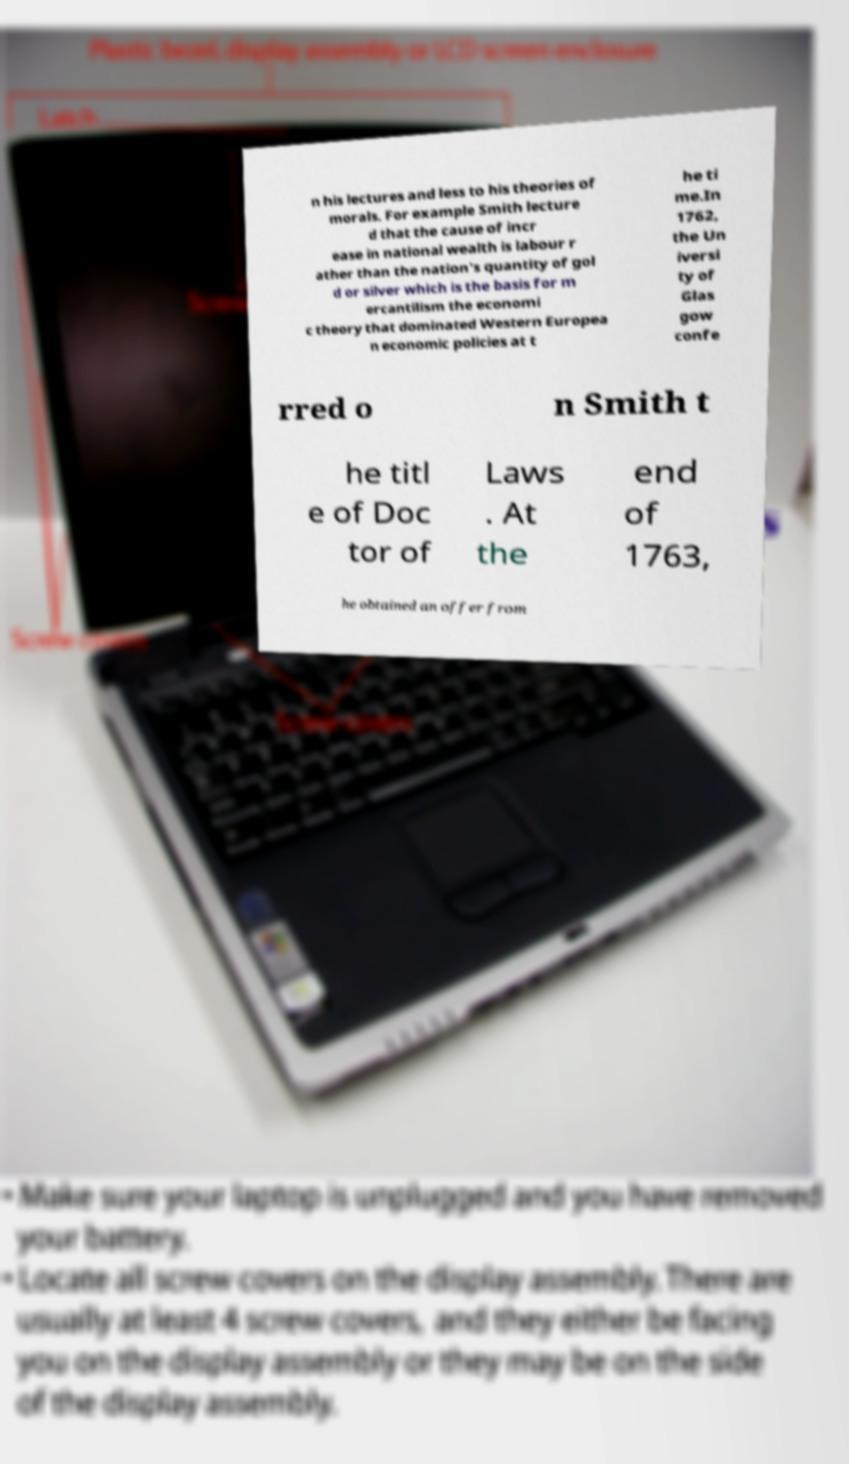Could you assist in decoding the text presented in this image and type it out clearly? n his lectures and less to his theories of morals. For example Smith lecture d that the cause of incr ease in national wealth is labour r ather than the nation's quantity of gol d or silver which is the basis for m ercantilism the economi c theory that dominated Western Europea n economic policies at t he ti me.In 1762, the Un iversi ty of Glas gow confe rred o n Smith t he titl e of Doc tor of Laws . At the end of 1763, he obtained an offer from 